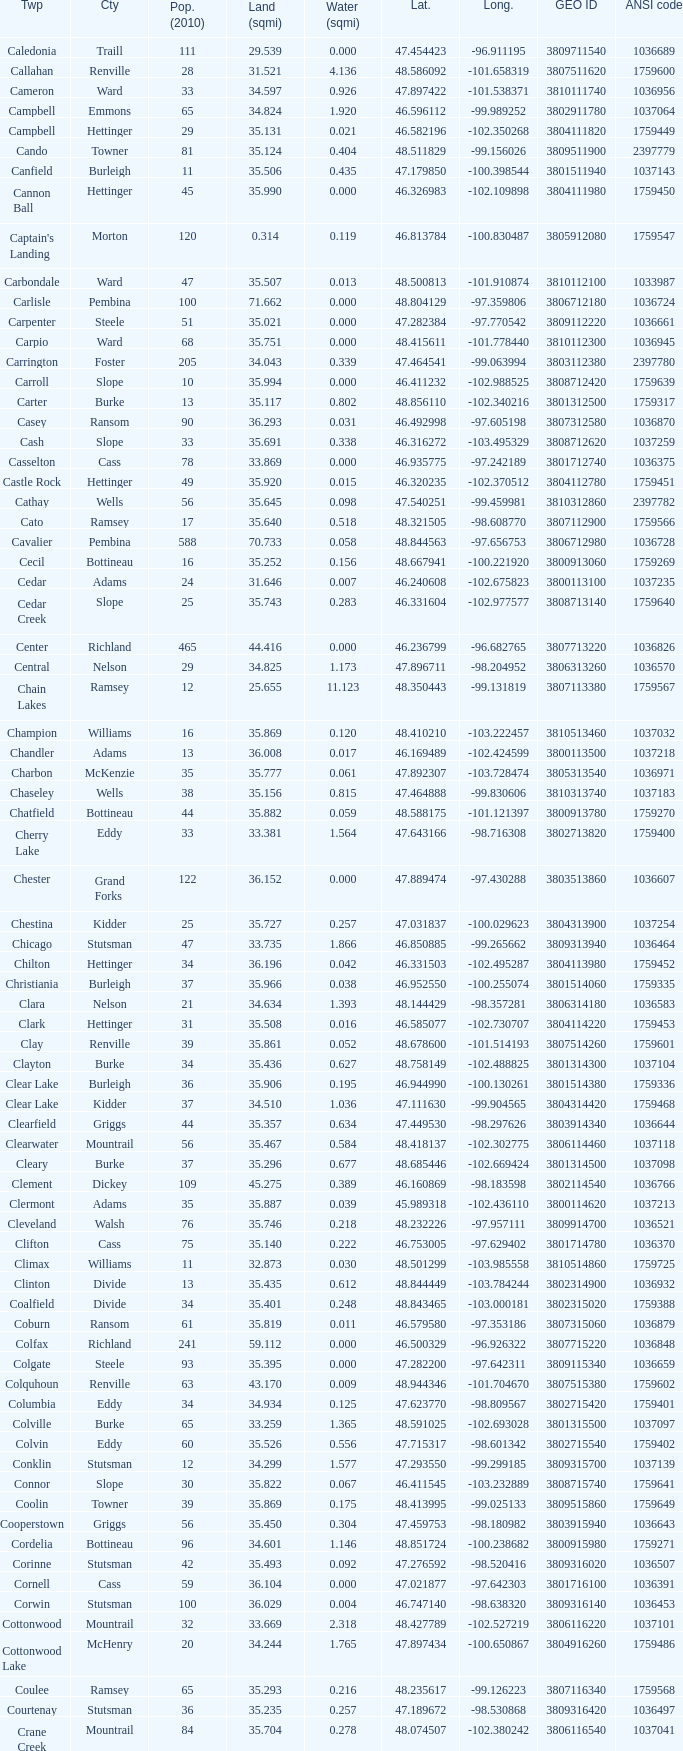What was the land area in sqmi that has a latitude of 48.763937? 35.898. 